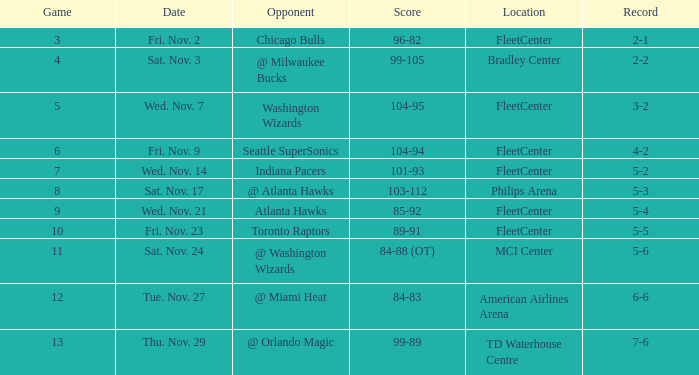In what contest is the score 89-91? 10.0. 